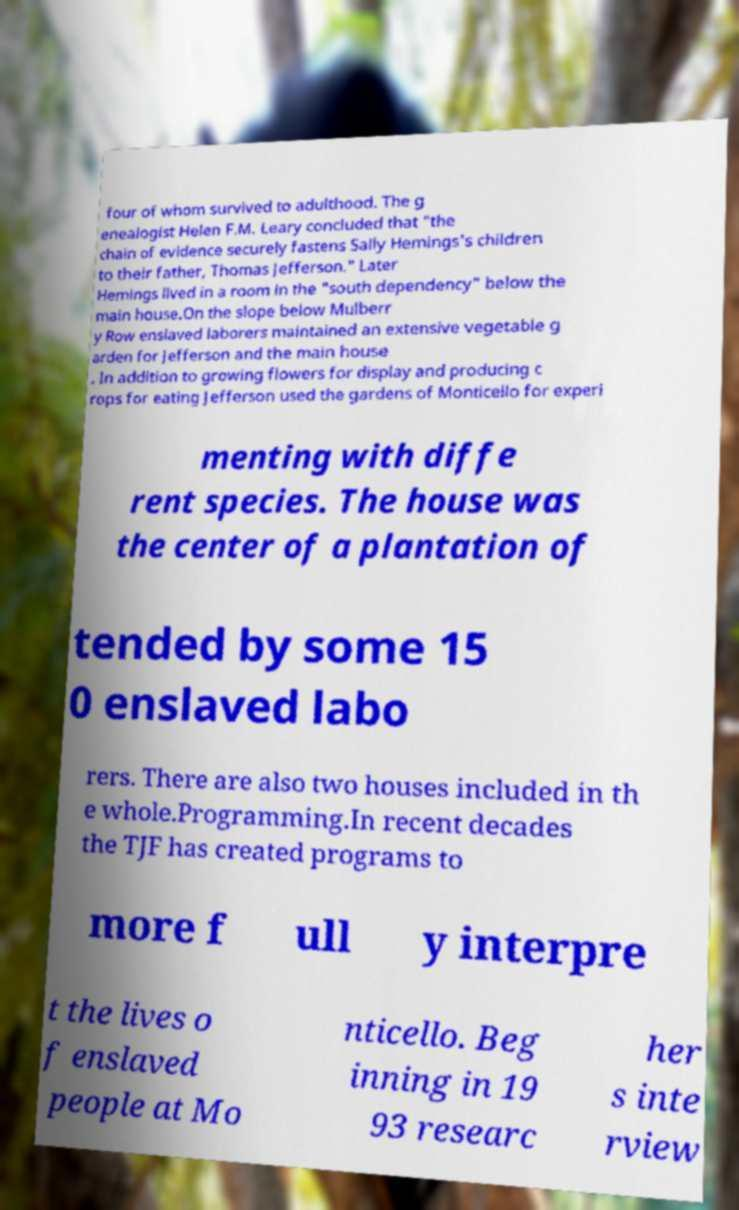There's text embedded in this image that I need extracted. Can you transcribe it verbatim? four of whom survived to adulthood. The g enealogist Helen F.M. Leary concluded that "the chain of evidence securely fastens Sally Hemings's children to their father, Thomas Jefferson." Later Hemings lived in a room in the "south dependency" below the main house.On the slope below Mulberr y Row enslaved laborers maintained an extensive vegetable g arden for Jefferson and the main house . In addition to growing flowers for display and producing c rops for eating Jefferson used the gardens of Monticello for experi menting with diffe rent species. The house was the center of a plantation of tended by some 15 0 enslaved labo rers. There are also two houses included in th e whole.Programming.In recent decades the TJF has created programs to more f ull y interpre t the lives o f enslaved people at Mo nticello. Beg inning in 19 93 researc her s inte rview 